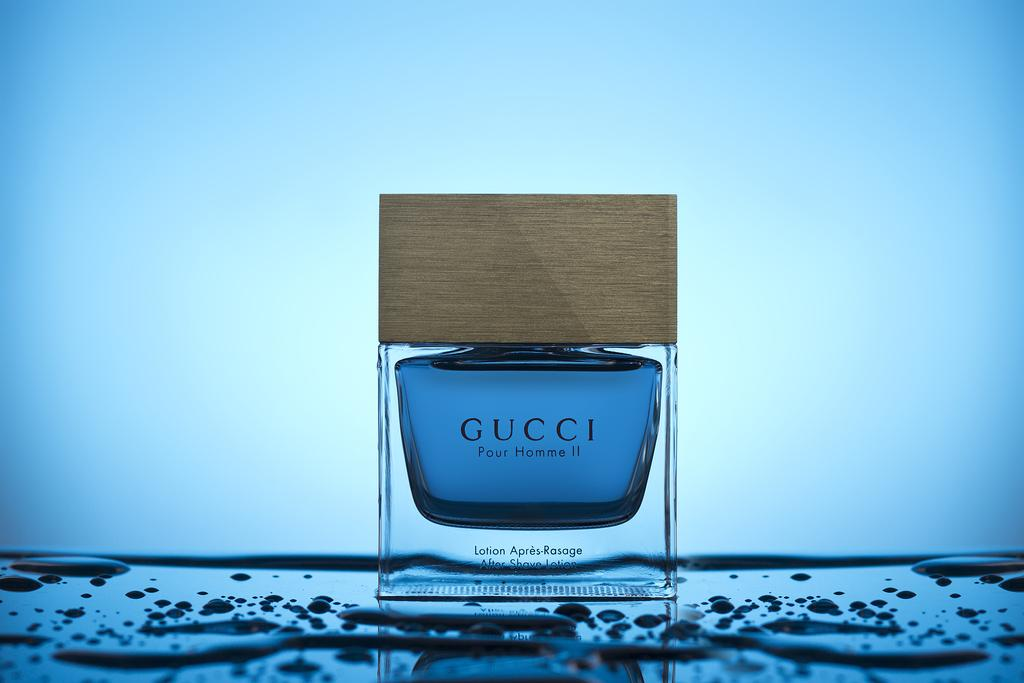<image>
Describe the image concisely. An advertisement for a cologne from the Gucci brand 